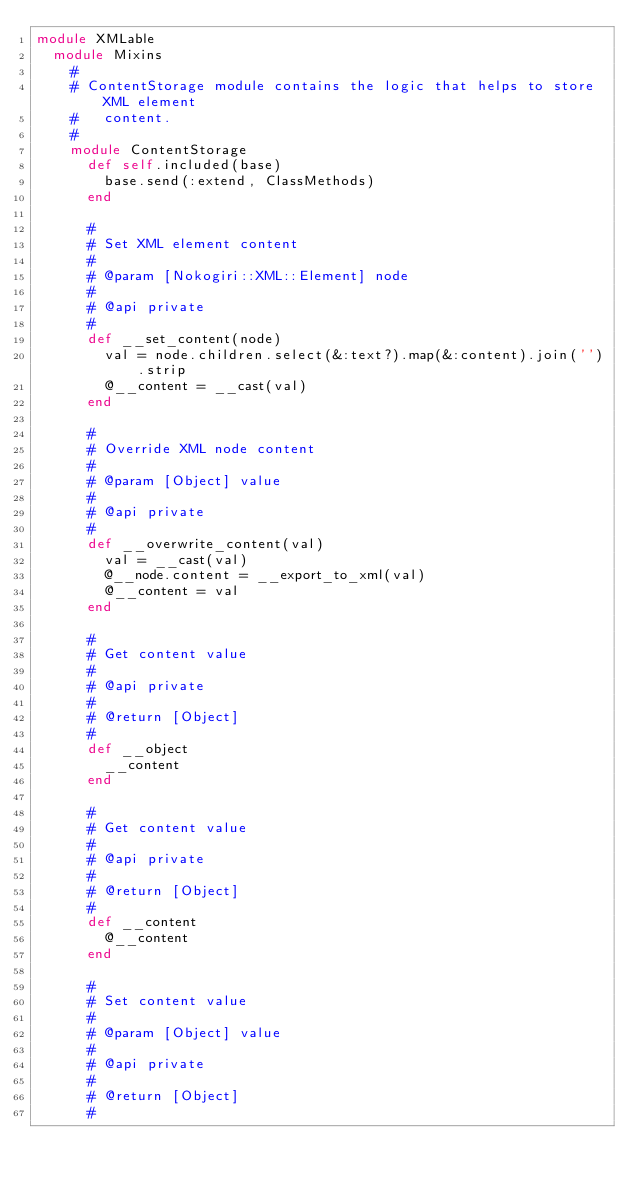<code> <loc_0><loc_0><loc_500><loc_500><_Ruby_>module XMLable
  module Mixins
    #
    # ContentStorage module contains the logic that helps to store XML element
    #   content.
    #
    module ContentStorage
      def self.included(base)
        base.send(:extend, ClassMethods)
      end

      #
      # Set XML element content
      #
      # @param [Nokogiri::XML::Element] node
      #
      # @api private
      #
      def __set_content(node)
        val = node.children.select(&:text?).map(&:content).join('').strip
        @__content = __cast(val)
      end

      #
      # Override XML node content
      #
      # @param [Object] value
      #
      # @api private
      #
      def __overwrite_content(val)
        val = __cast(val)
        @__node.content = __export_to_xml(val)
        @__content = val
      end

      #
      # Get content value
      #
      # @api private
      #
      # @return [Object]
      #
      def __object
        __content
      end

      #
      # Get content value
      #
      # @api private
      #
      # @return [Object]
      #
      def __content
        @__content
      end

      #
      # Set content value
      #
      # @param [Object] value
      #
      # @api private
      #
      # @return [Object]
      #</code> 